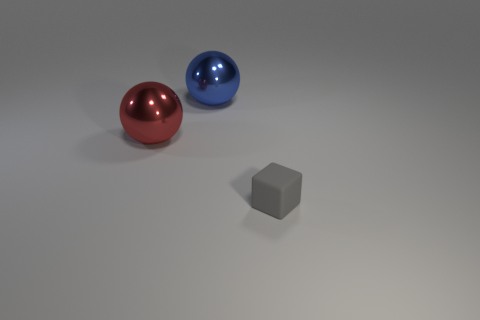What number of small objects are either red balls or blue balls?
Keep it short and to the point. 0. Are there an equal number of tiny rubber things behind the large red sphere and big red things?
Your response must be concise. No. There is a tiny gray rubber cube; are there any gray cubes to the right of it?
Ensure brevity in your answer.  No. How many rubber things are large purple cylinders or tiny gray things?
Offer a terse response. 1. There is a big red sphere; how many blue metal balls are in front of it?
Provide a succinct answer. 0. Is there a red sphere of the same size as the gray cube?
Your answer should be very brief. No. Are there any objects that have the same color as the block?
Your response must be concise. No. Are there any other things that have the same size as the blue sphere?
Keep it short and to the point. Yes. How many spheres are the same color as the small matte thing?
Ensure brevity in your answer.  0. There is a small object; is its color the same as the large thing that is in front of the big blue sphere?
Provide a succinct answer. No. 